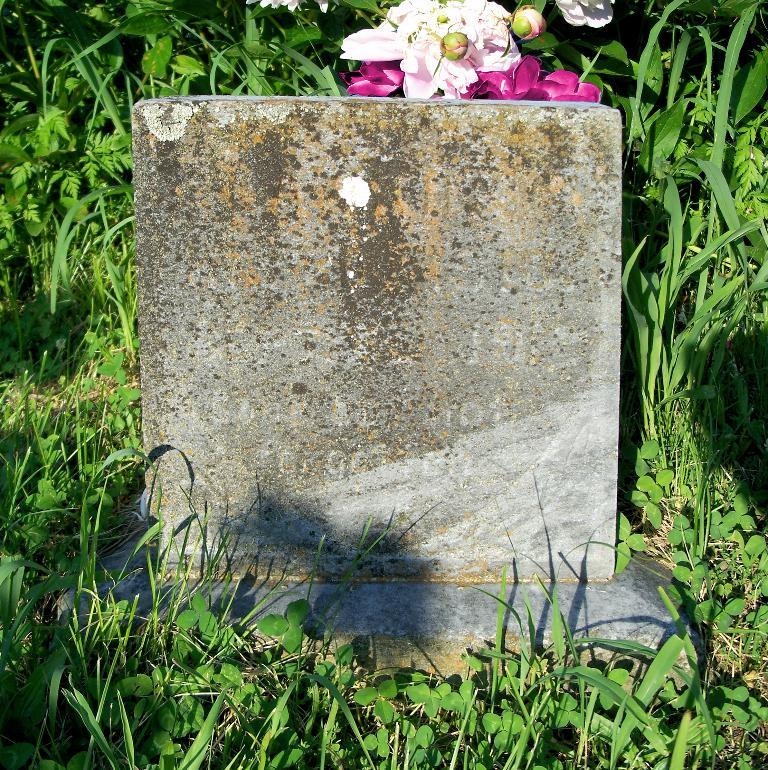What type of vegetation is at the bottom of the image? There is grass at the bottom of the image. What object is located in the middle of the image? There is a stone in the middle of the image. What type of plants are at the top of the image? There are flowers at the top of the image. How many cubs can be seen playing with the flowers at the top of the image? There are no cubs present in the image; it features grass, a stone, and flowers. What is the limit of cars that can be parked on the grass at the bottom of the image? There are no cars present in the image; it features grass, a stone, and flowers. 